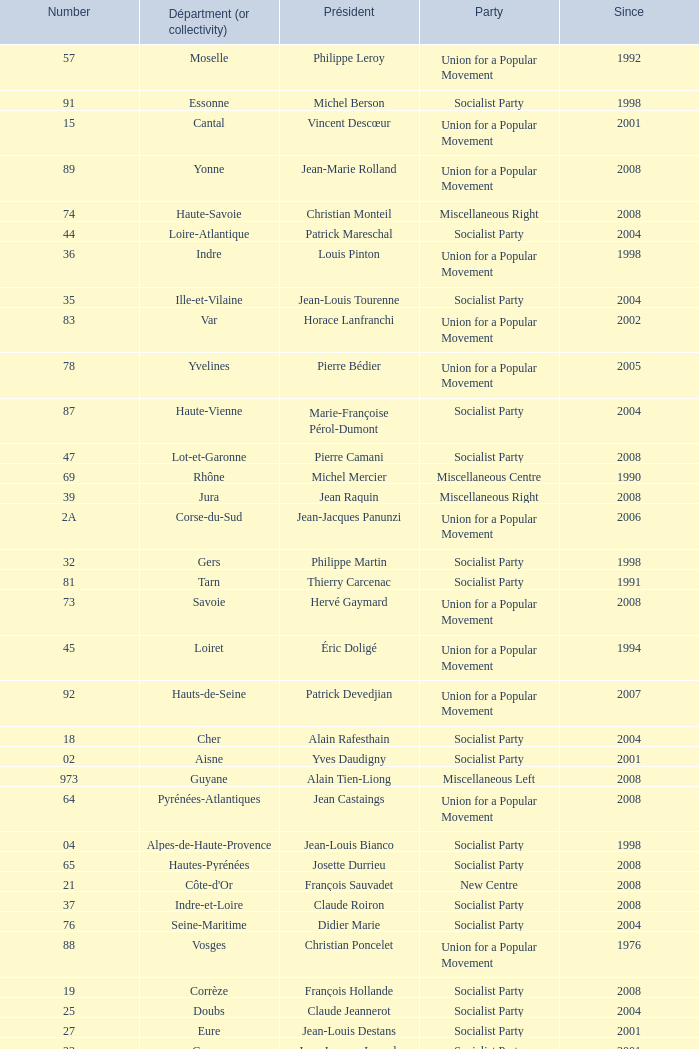Who is the president from the Union for a Popular Movement party that represents the Hautes-Alpes department? Jean-Yves Dusserre. 